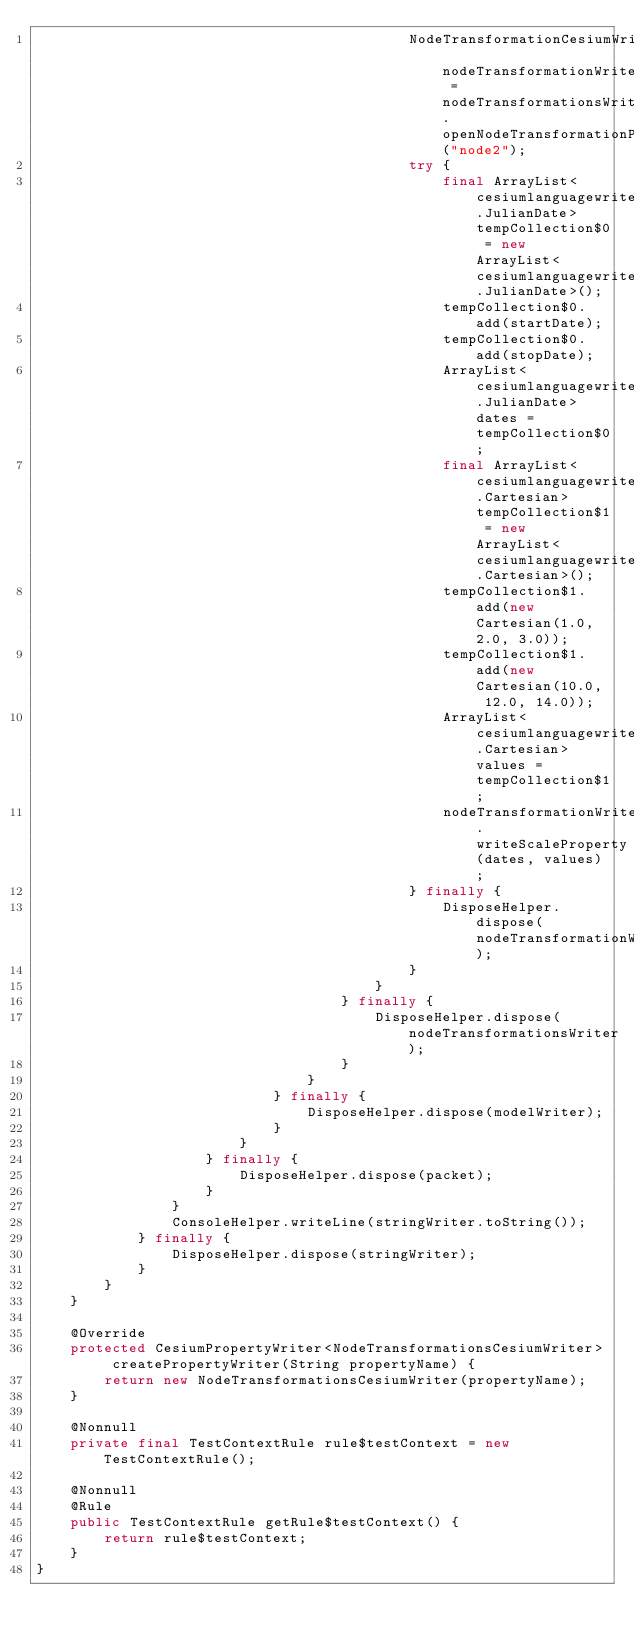<code> <loc_0><loc_0><loc_500><loc_500><_Java_>                                            NodeTransformationCesiumWriter nodeTransformationWriter = nodeTransformationsWriter.openNodeTransformationProperty("node2");
                                            try {
                                                final ArrayList<cesiumlanguagewriter.JulianDate> tempCollection$0 = new ArrayList<cesiumlanguagewriter.JulianDate>();
                                                tempCollection$0.add(startDate);
                                                tempCollection$0.add(stopDate);
                                                ArrayList<cesiumlanguagewriter.JulianDate> dates = tempCollection$0;
                                                final ArrayList<cesiumlanguagewriter.Cartesian> tempCollection$1 = new ArrayList<cesiumlanguagewriter.Cartesian>();
                                                tempCollection$1.add(new Cartesian(1.0, 2.0, 3.0));
                                                tempCollection$1.add(new Cartesian(10.0, 12.0, 14.0));
                                                ArrayList<cesiumlanguagewriter.Cartesian> values = tempCollection$1;
                                                nodeTransformationWriter.writeScaleProperty(dates, values);
                                            } finally {
                                                DisposeHelper.dispose(nodeTransformationWriter);
                                            }
                                        }
                                    } finally {
                                        DisposeHelper.dispose(nodeTransformationsWriter);
                                    }
                                }
                            } finally {
                                DisposeHelper.dispose(modelWriter);
                            }
                        }
                    } finally {
                        DisposeHelper.dispose(packet);
                    }
                }
                ConsoleHelper.writeLine(stringWriter.toString());
            } finally {
                DisposeHelper.dispose(stringWriter);
            }
        }
    }

    @Override
    protected CesiumPropertyWriter<NodeTransformationsCesiumWriter> createPropertyWriter(String propertyName) {
        return new NodeTransformationsCesiumWriter(propertyName);
    }

    @Nonnull
    private final TestContextRule rule$testContext = new TestContextRule();

    @Nonnull
    @Rule
    public TestContextRule getRule$testContext() {
        return rule$testContext;
    }
}</code> 